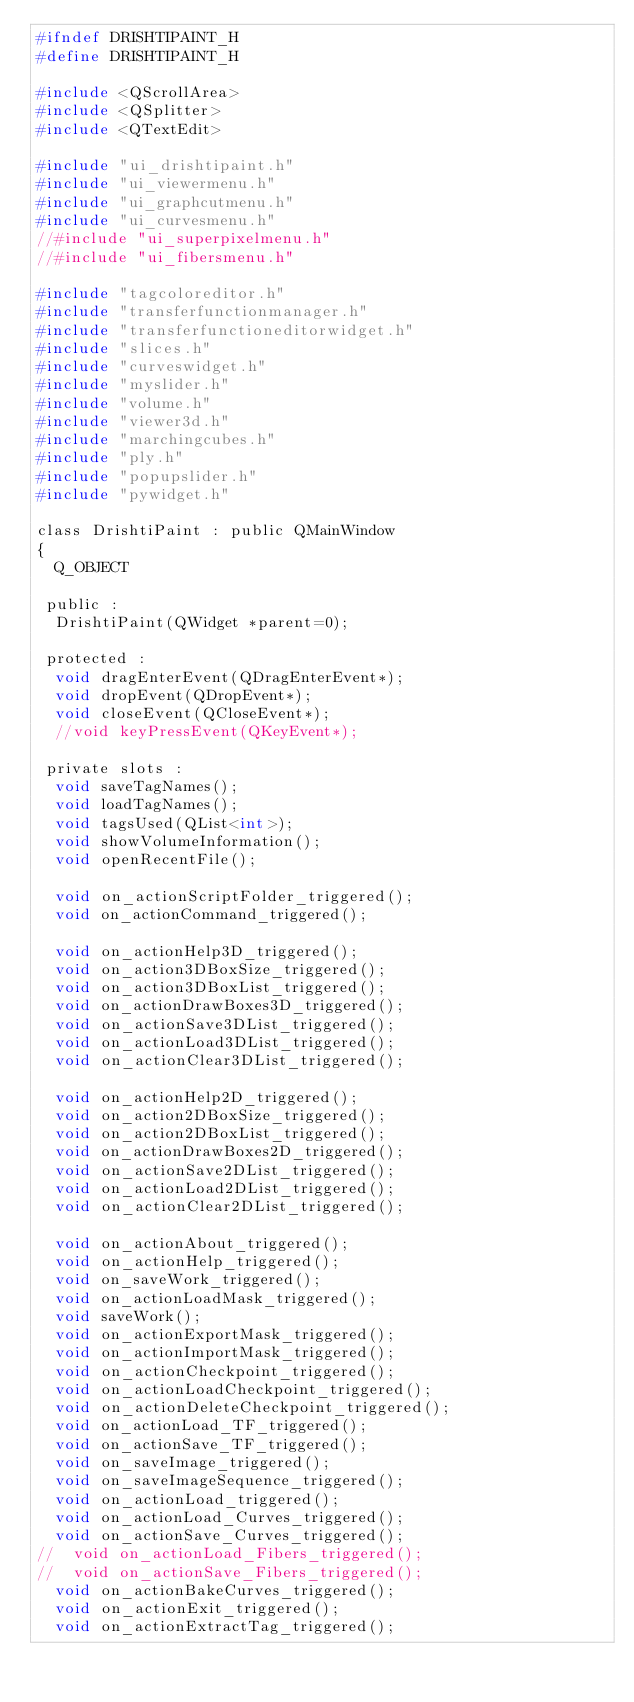<code> <loc_0><loc_0><loc_500><loc_500><_C_>#ifndef DRISHTIPAINT_H
#define DRISHTIPAINT_H

#include <QScrollArea>
#include <QSplitter>
#include <QTextEdit>

#include "ui_drishtipaint.h"
#include "ui_viewermenu.h"
#include "ui_graphcutmenu.h"
#include "ui_curvesmenu.h"
//#include "ui_superpixelmenu.h"
//#include "ui_fibersmenu.h"

#include "tagcoloreditor.h"
#include "transferfunctionmanager.h"
#include "transferfunctioneditorwidget.h"
#include "slices.h"
#include "curveswidget.h"
#include "myslider.h"
#include "volume.h"
#include "viewer3d.h"
#include "marchingcubes.h"
#include "ply.h"
#include "popupslider.h"
#include "pywidget.h"

class DrishtiPaint : public QMainWindow
{
  Q_OBJECT

 public :
  DrishtiPaint(QWidget *parent=0);

 protected :
  void dragEnterEvent(QDragEnterEvent*);
  void dropEvent(QDropEvent*);
  void closeEvent(QCloseEvent*);
  //void keyPressEvent(QKeyEvent*);

 private slots :
  void saveTagNames();
  void loadTagNames();
  void tagsUsed(QList<int>);
  void showVolumeInformation();
  void openRecentFile();   

  void on_actionScriptFolder_triggered();
  void on_actionCommand_triggered();

  void on_actionHelp3D_triggered();
  void on_action3DBoxSize_triggered();
  void on_action3DBoxList_triggered();
  void on_actionDrawBoxes3D_triggered();
  void on_actionSave3DList_triggered();
  void on_actionLoad3DList_triggered();
  void on_actionClear3DList_triggered();

  void on_actionHelp2D_triggered();
  void on_action2DBoxSize_triggered();
  void on_action2DBoxList_triggered();
  void on_actionDrawBoxes2D_triggered();
  void on_actionSave2DList_triggered();
  void on_actionLoad2DList_triggered();
  void on_actionClear2DList_triggered();

  void on_actionAbout_triggered();
  void on_actionHelp_triggered();
  void on_saveWork_triggered();
  void on_actionLoadMask_triggered();
  void saveWork();
  void on_actionExportMask_triggered();
  void on_actionImportMask_triggered();
  void on_actionCheckpoint_triggered();
  void on_actionLoadCheckpoint_triggered();
  void on_actionDeleteCheckpoint_triggered();
  void on_actionLoad_TF_triggered();
  void on_actionSave_TF_triggered();
  void on_saveImage_triggered();
  void on_saveImageSequence_triggered();
  void on_actionLoad_triggered();
  void on_actionLoad_Curves_triggered();
  void on_actionSave_Curves_triggered();
//  void on_actionLoad_Fibers_triggered();
//  void on_actionSave_Fibers_triggered();
  void on_actionBakeCurves_triggered();
  void on_actionExit_triggered();
  void on_actionExtractTag_triggered();</code> 